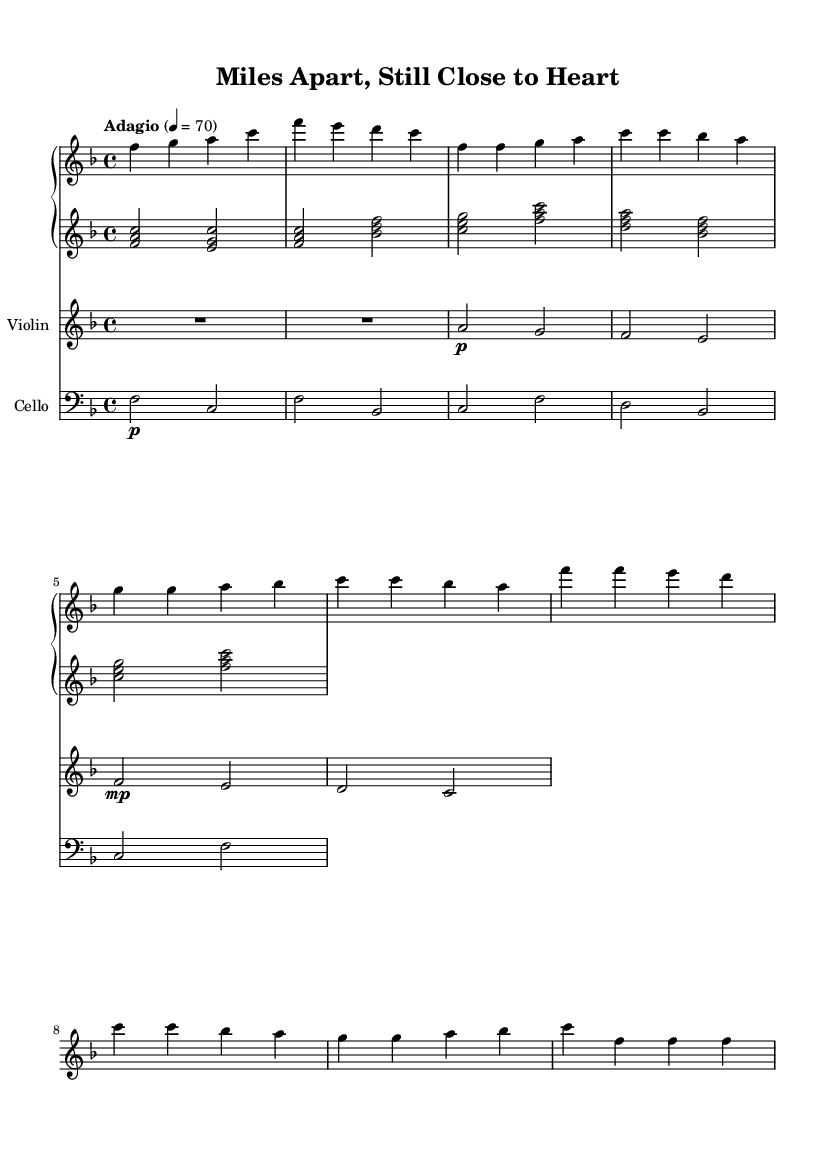What is the key signature of this music? The key signature is indicated at the beginning of the staff. Here, the key signature has one flat, which corresponds to F major.
Answer: F major What is the time signature of this music? The time signature is found at the beginning of the score. It displays "4/4," meaning there are four beats in each measure and a quarter note receives one beat.
Answer: 4/4 What is the tempo marking of this piece? The tempo is indicated above the music staff. It shows "Adagio" with a metronome marking of 70, which signifies a slow and relaxed pace.
Answer: Adagio, 70 How many measures are in the intro section? To find the number of measures, we need to count the musical phrases within the intro part. The intro consists of 2 measures as written clearly in the score.
Answer: 2 Which instrument has the highest pitch in this score? By comparing the written notes across the instruments, the violin plays the highest pitch consistently throughout the piece.
Answer: Violin What chord is played in the left hand during the intro? The left hand of the piano plays a chord comprising the notes F, A, and C, which forms an F major chord in the left hand during the intro.
Answer: F major What dynamic marking is indicated for the violin in the verse? The dynamic marking for the violin in the verse is indicated as "p," which stands for "piano" meaning to play softly in dynamics.
Answer: Piano 